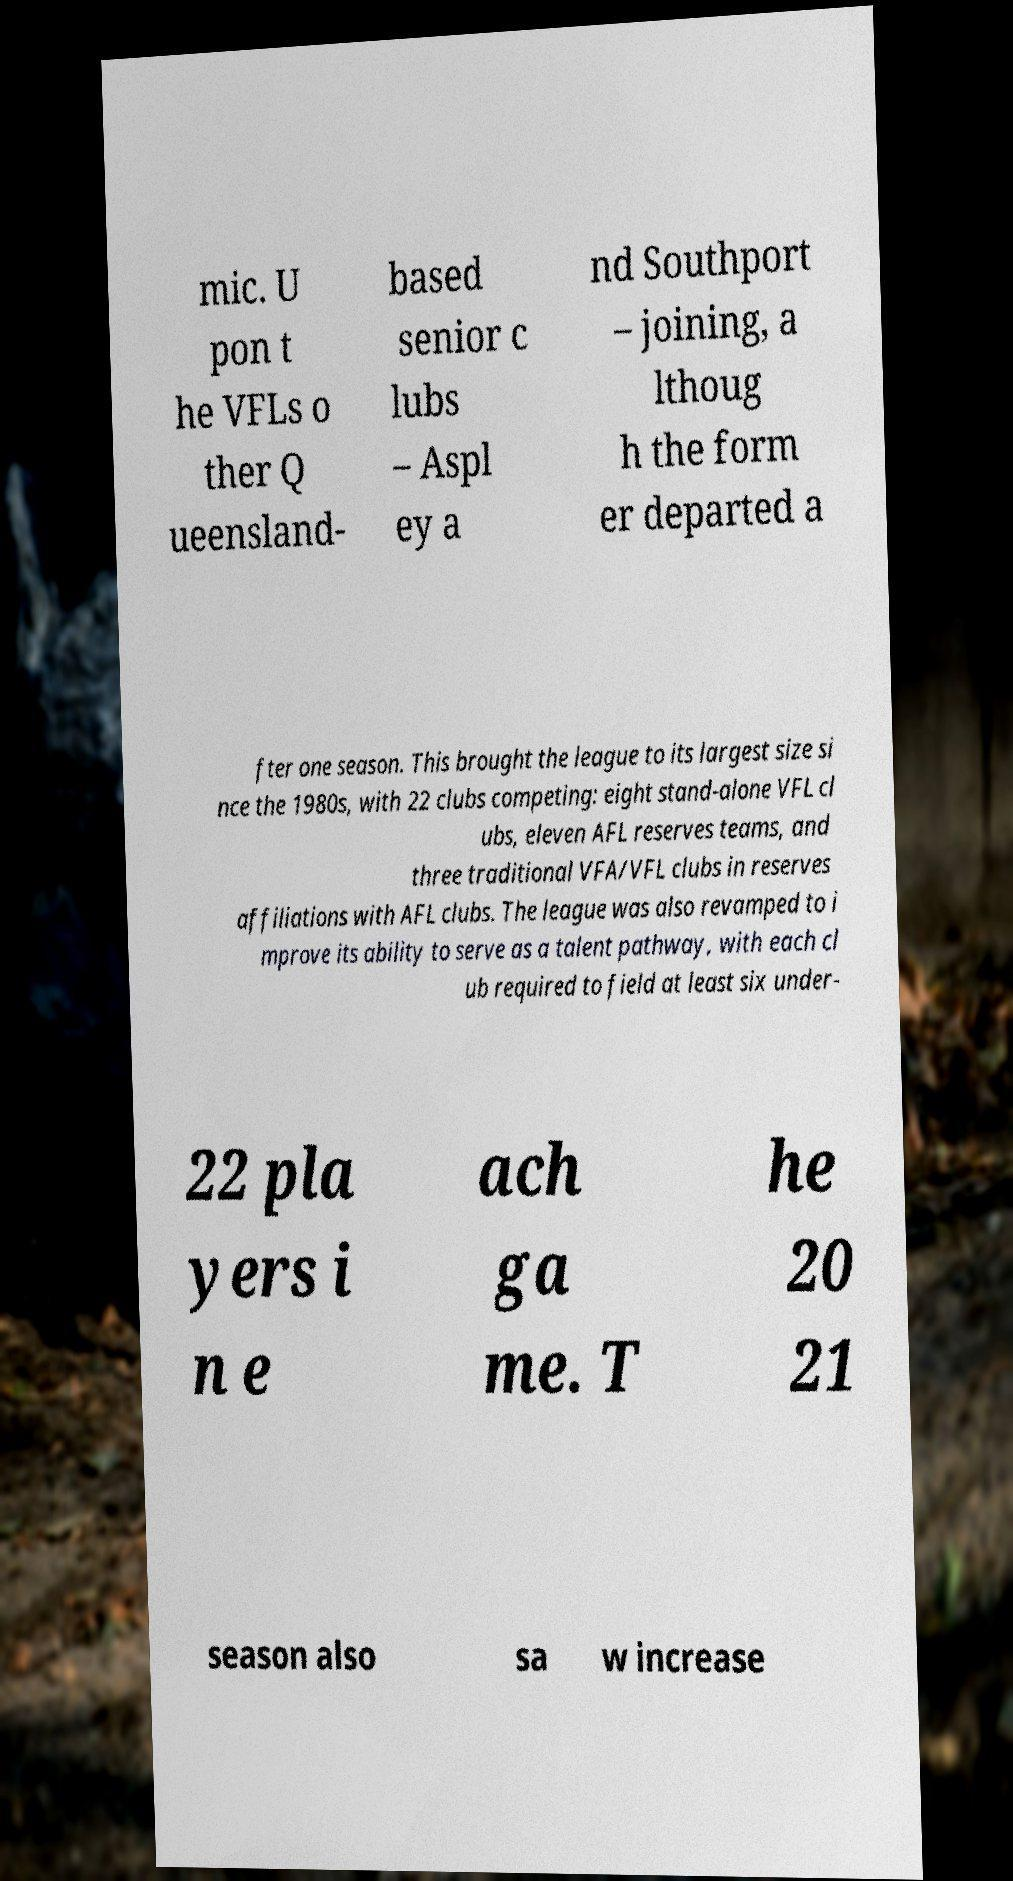What messages or text are displayed in this image? I need them in a readable, typed format. mic. U pon t he VFLs o ther Q ueensland- based senior c lubs – Aspl ey a nd Southport – joining, a lthoug h the form er departed a fter one season. This brought the league to its largest size si nce the 1980s, with 22 clubs competing: eight stand-alone VFL cl ubs, eleven AFL reserves teams, and three traditional VFA/VFL clubs in reserves affiliations with AFL clubs. The league was also revamped to i mprove its ability to serve as a talent pathway, with each cl ub required to field at least six under- 22 pla yers i n e ach ga me. T he 20 21 season also sa w increase 